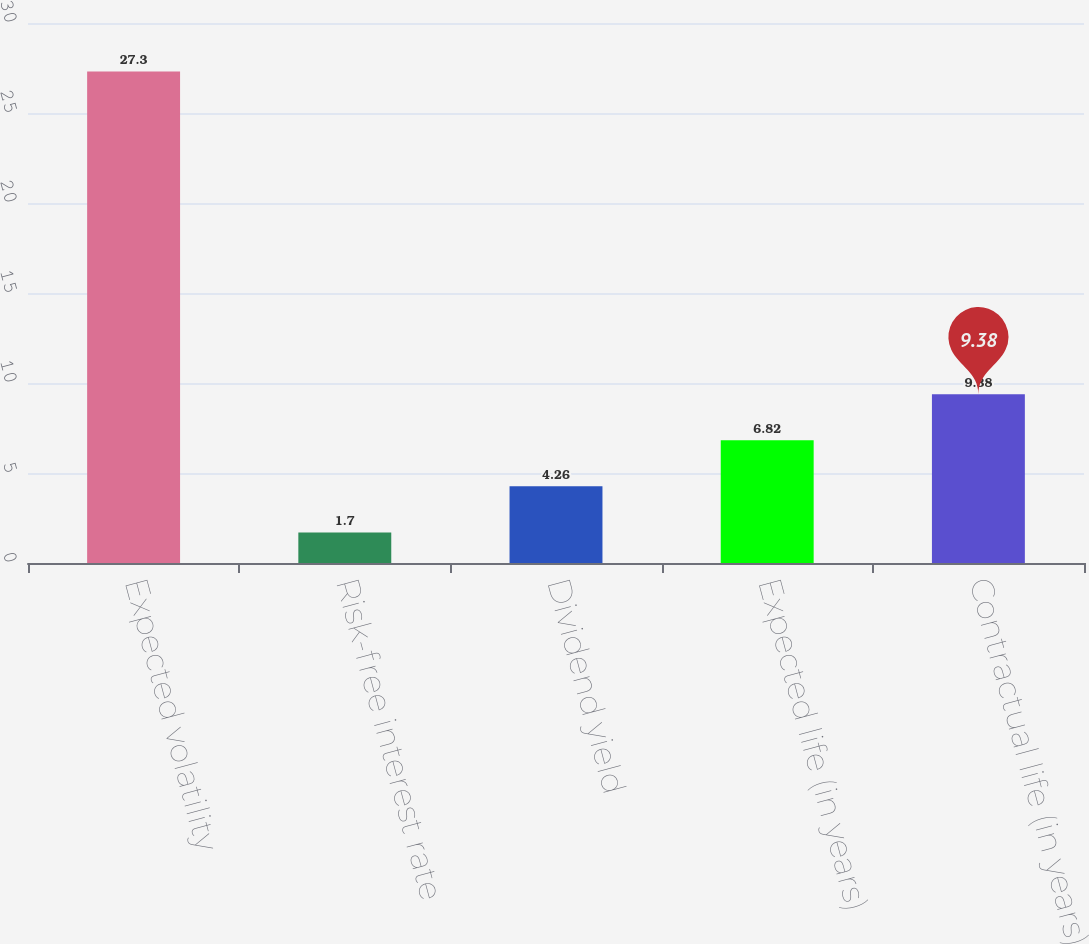Convert chart to OTSL. <chart><loc_0><loc_0><loc_500><loc_500><bar_chart><fcel>Expected volatility<fcel>Risk-free interest rate<fcel>Dividend yield<fcel>Expected life (in years)<fcel>Contractual life (in years)<nl><fcel>27.3<fcel>1.7<fcel>4.26<fcel>6.82<fcel>9.38<nl></chart> 